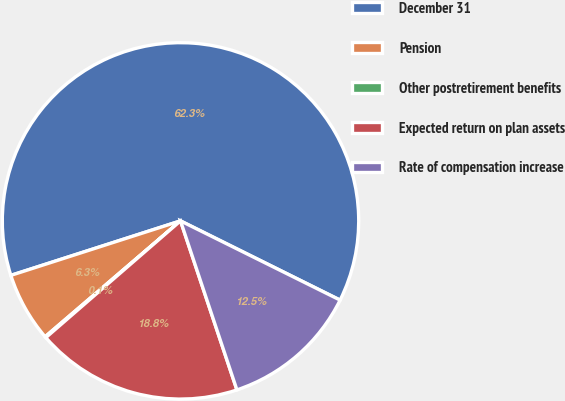<chart> <loc_0><loc_0><loc_500><loc_500><pie_chart><fcel>December 31<fcel>Pension<fcel>Other postretirement benefits<fcel>Expected return on plan assets<fcel>Rate of compensation increase<nl><fcel>62.28%<fcel>6.32%<fcel>0.1%<fcel>18.76%<fcel>12.54%<nl></chart> 